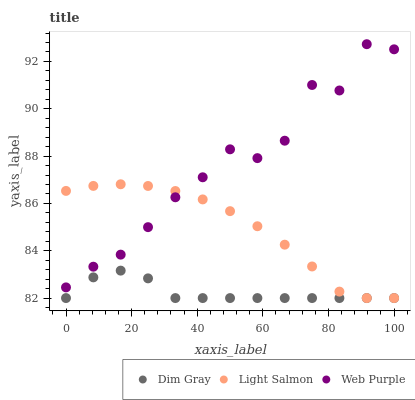Does Dim Gray have the minimum area under the curve?
Answer yes or no. Yes. Does Web Purple have the maximum area under the curve?
Answer yes or no. Yes. Does Web Purple have the minimum area under the curve?
Answer yes or no. No. Does Dim Gray have the maximum area under the curve?
Answer yes or no. No. Is Light Salmon the smoothest?
Answer yes or no. Yes. Is Web Purple the roughest?
Answer yes or no. Yes. Is Dim Gray the smoothest?
Answer yes or no. No. Is Dim Gray the roughest?
Answer yes or no. No. Does Light Salmon have the lowest value?
Answer yes or no. Yes. Does Web Purple have the lowest value?
Answer yes or no. No. Does Web Purple have the highest value?
Answer yes or no. Yes. Does Dim Gray have the highest value?
Answer yes or no. No. Is Dim Gray less than Web Purple?
Answer yes or no. Yes. Is Web Purple greater than Dim Gray?
Answer yes or no. Yes. Does Web Purple intersect Light Salmon?
Answer yes or no. Yes. Is Web Purple less than Light Salmon?
Answer yes or no. No. Is Web Purple greater than Light Salmon?
Answer yes or no. No. Does Dim Gray intersect Web Purple?
Answer yes or no. No. 